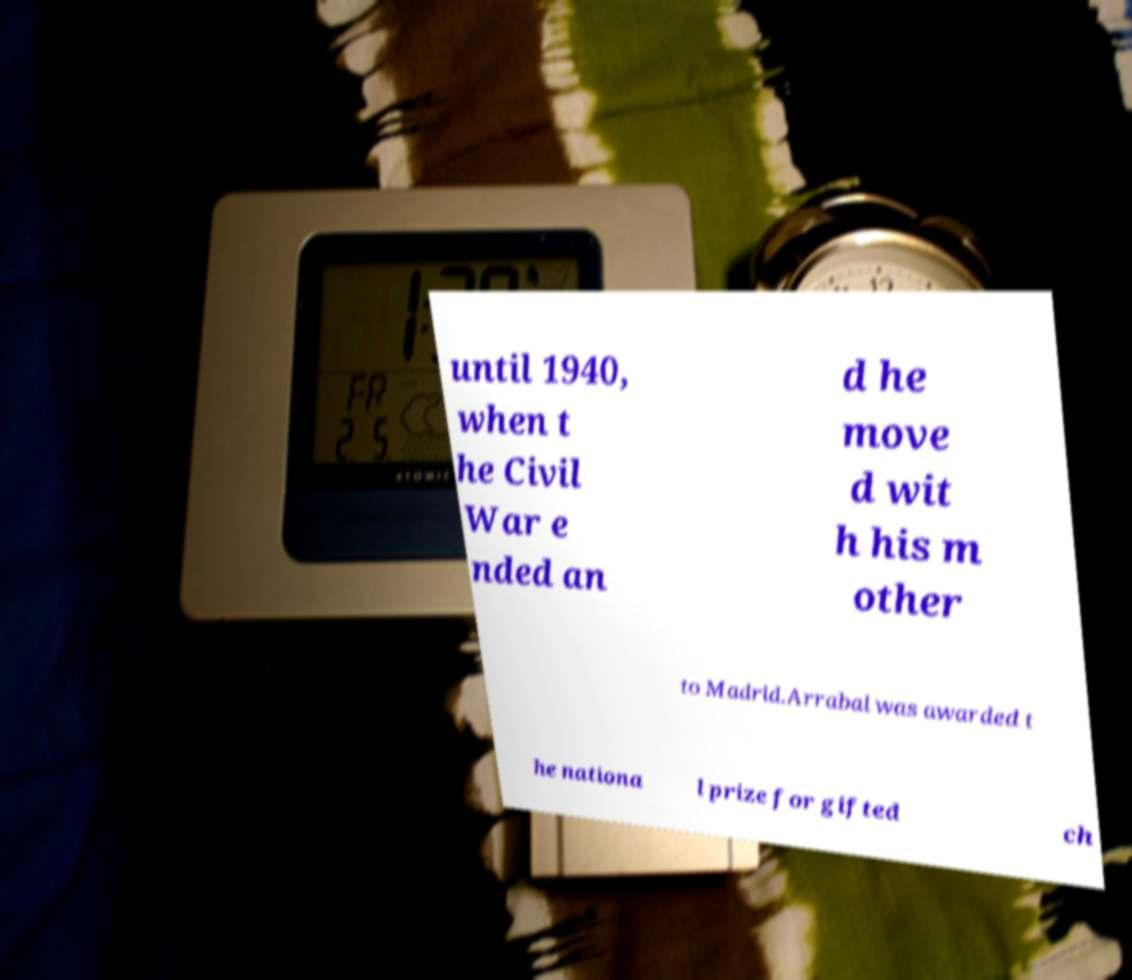Please identify and transcribe the text found in this image. until 1940, when t he Civil War e nded an d he move d wit h his m other to Madrid.Arrabal was awarded t he nationa l prize for gifted ch 